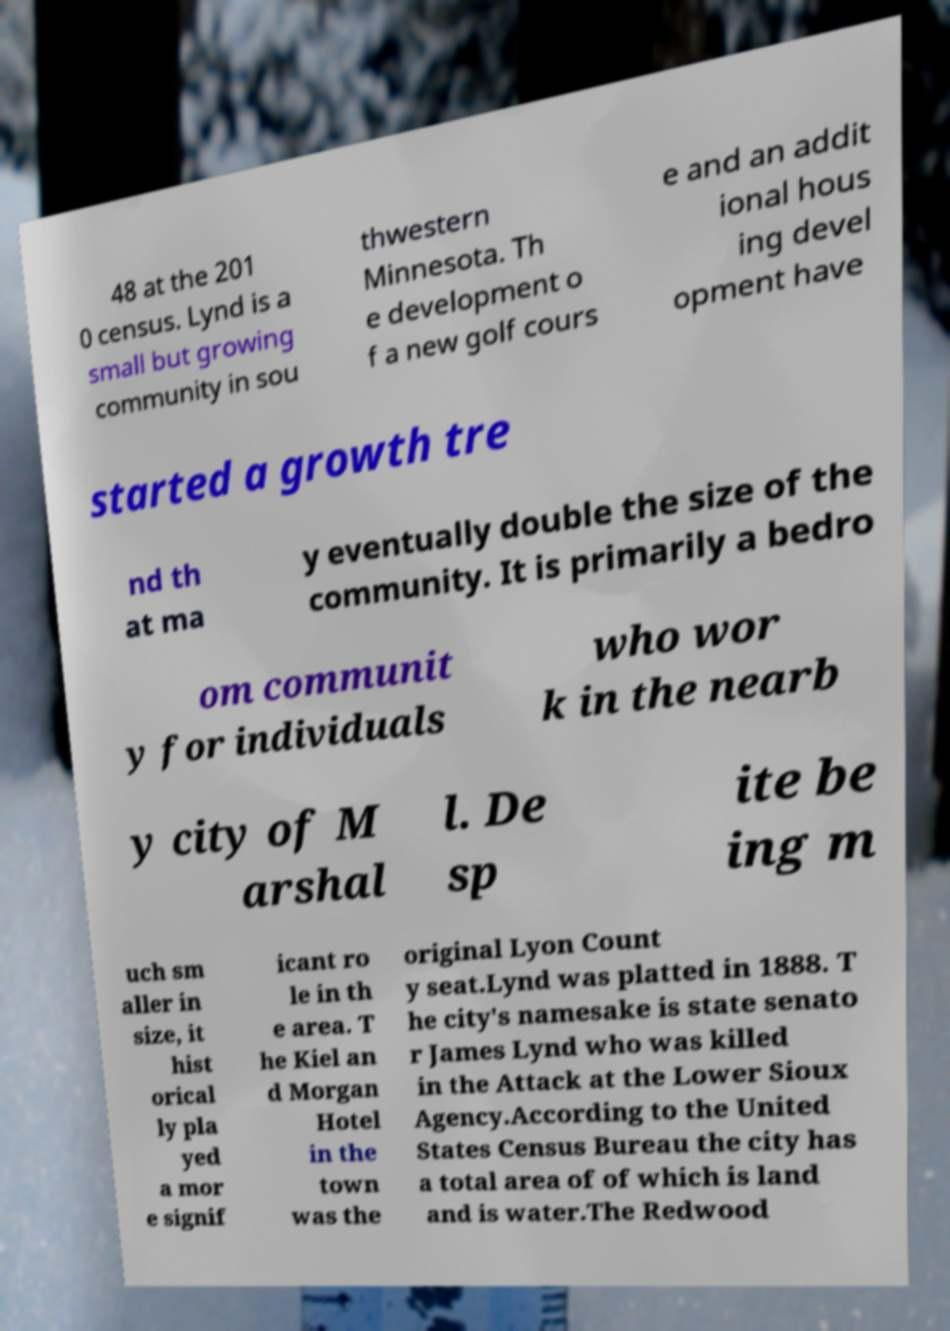Can you read and provide the text displayed in the image?This photo seems to have some interesting text. Can you extract and type it out for me? 48 at the 201 0 census. Lynd is a small but growing community in sou thwestern Minnesota. Th e development o f a new golf cours e and an addit ional hous ing devel opment have started a growth tre nd th at ma y eventually double the size of the community. It is primarily a bedro om communit y for individuals who wor k in the nearb y city of M arshal l. De sp ite be ing m uch sm aller in size, it hist orical ly pla yed a mor e signif icant ro le in th e area. T he Kiel an d Morgan Hotel in the town was the original Lyon Count y seat.Lynd was platted in 1888. T he city's namesake is state senato r James Lynd who was killed in the Attack at the Lower Sioux Agency.According to the United States Census Bureau the city has a total area of of which is land and is water.The Redwood 